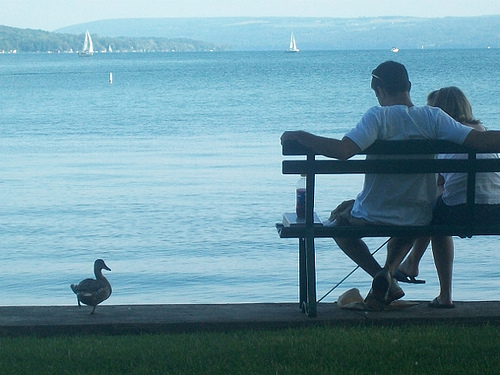<image>
Is there a sky behind the mountain? Yes. From this viewpoint, the sky is positioned behind the mountain, with the mountain partially or fully occluding the sky. Is the man to the right of the woman? No. The man is not to the right of the woman. The horizontal positioning shows a different relationship. 